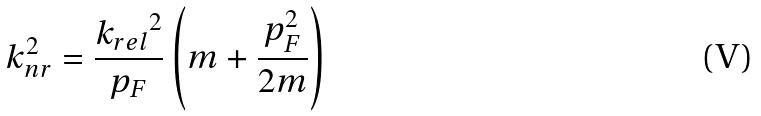<formula> <loc_0><loc_0><loc_500><loc_500>k _ { n r } ^ { 2 } = \frac { { k _ { r e l } } ^ { 2 } } { p _ { F } } \left ( m + \frac { p _ { F } ^ { 2 } } { 2 m } \right )</formula> 